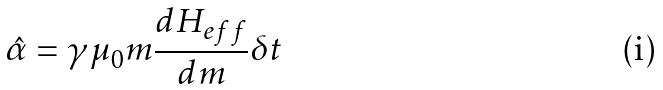Convert formula to latex. <formula><loc_0><loc_0><loc_500><loc_500>\hat { \alpha } = \gamma \mu _ { 0 } m \frac { d H _ { e f f } } { d m } \delta t</formula> 